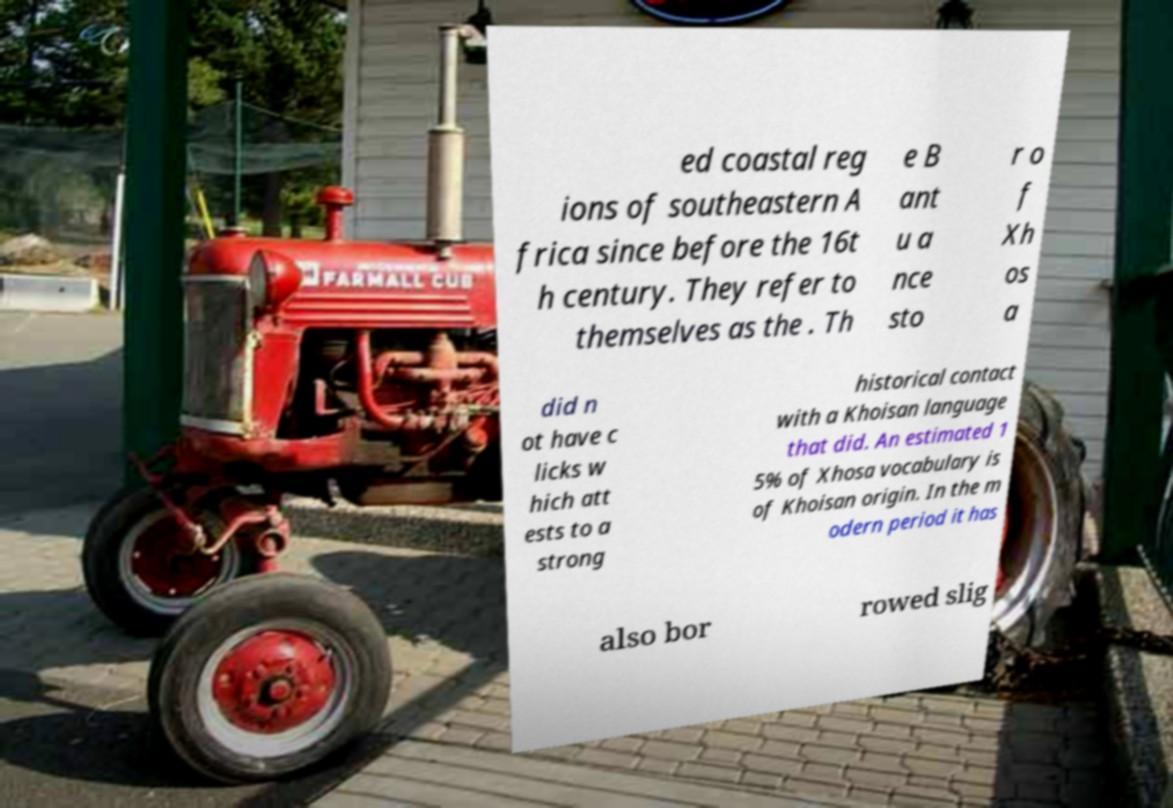Can you accurately transcribe the text from the provided image for me? ed coastal reg ions of southeastern A frica since before the 16t h century. They refer to themselves as the . Th e B ant u a nce sto r o f Xh os a did n ot have c licks w hich att ests to a strong historical contact with a Khoisan language that did. An estimated 1 5% of Xhosa vocabulary is of Khoisan origin. In the m odern period it has also bor rowed slig 